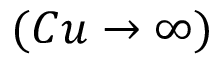Convert formula to latex. <formula><loc_0><loc_0><loc_500><loc_500>( C u \to \infty )</formula> 